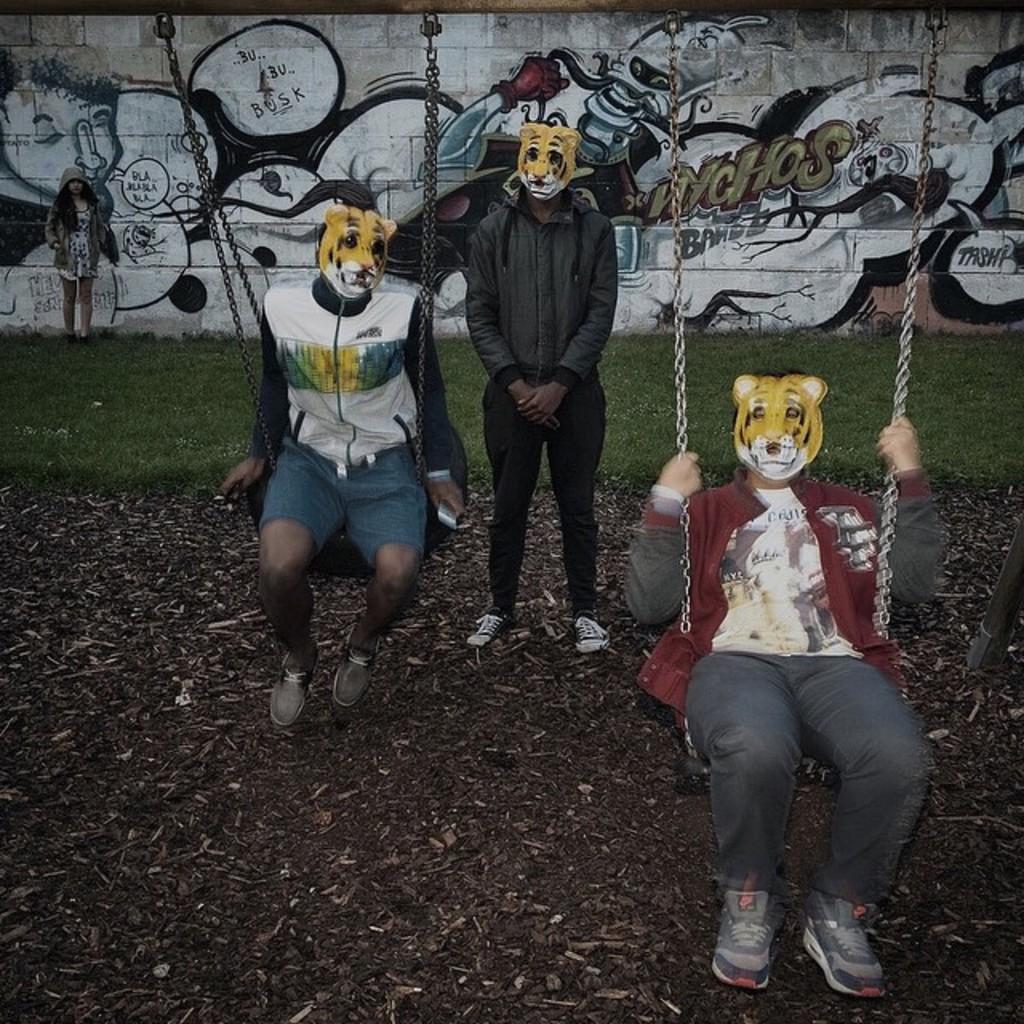In one or two sentences, can you explain what this image depicts? This image consist of two persons. They are sitting on the swings. There is a person standing in the middle. Three of them are wearing tiger masks. There is a wall behind them. There is a woman on the left side. 